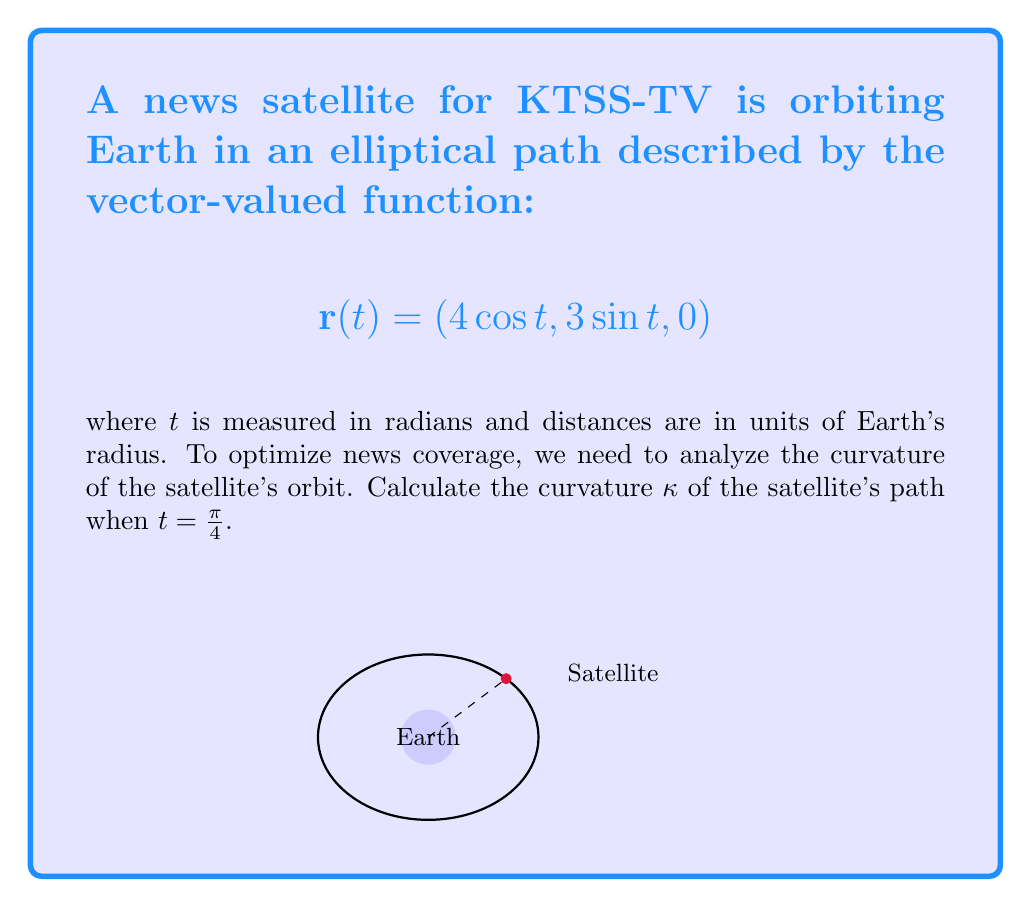Help me with this question. To find the curvature κ, we'll use the formula:

$$κ = \frac{|\mathbf{r}'(t) × \mathbf{r}''(t)|}{|\mathbf{r}'(t)|^3}$$

Step 1: Calculate $\mathbf{r}'(t)$
$$\mathbf{r}'(t) = (-4\sin t, 3\cos t, 0)$$

Step 2: Calculate $\mathbf{r}''(t)$
$$\mathbf{r}''(t) = (-4\cos t, -3\sin t, 0)$$

Step 3: Evaluate $\mathbf{r}'(t)$ and $\mathbf{r}''(t)$ at $t = π/4$
$$\mathbf{r}'(π/4) = (-2\sqrt{2}, 3\sqrt{2}/2, 0)$$
$$\mathbf{r}''(π/4) = (-2\sqrt{2}, -3\sqrt{2}/2, 0)$$

Step 4: Calculate $\mathbf{r}'(π/4) × \mathbf{r}''(π/4)$
$$\mathbf{r}'(π/4) × \mathbf{r}''(π/4) = (0, 0, -4\cdot3\sqrt{2}/2 - 2\sqrt{2}\cdot3\sqrt{2}/2) = (0, 0, -\frac{15}{2})$$

Step 5: Calculate $|\mathbf{r}'(π/4) × \mathbf{r}''(π/4)|$
$$|\mathbf{r}'(π/4) × \mathbf{r}''(π/4)| = \frac{15}{2}$$

Step 6: Calculate $|\mathbf{r}'(π/4)|^3$
$$|\mathbf{r}'(π/4)|^3 = ((-2\sqrt{2})^2 + (3\sqrt{2}/2)^2)^{3/2} = (8 + 9/2)^{3/2} = (\frac{25}{2})^{3/2}$$

Step 7: Apply the curvature formula
$$κ = \frac{|\mathbf{r}'(π/4) × \mathbf{r}''(π/4)|}{|\mathbf{r}'(π/4)|^3} = \frac{15/2}{(25/2)^{3/2}} = \frac{15}{25\sqrt{25/2}}$$
Answer: $κ = \frac{15}{25\sqrt{25/2}}$ 